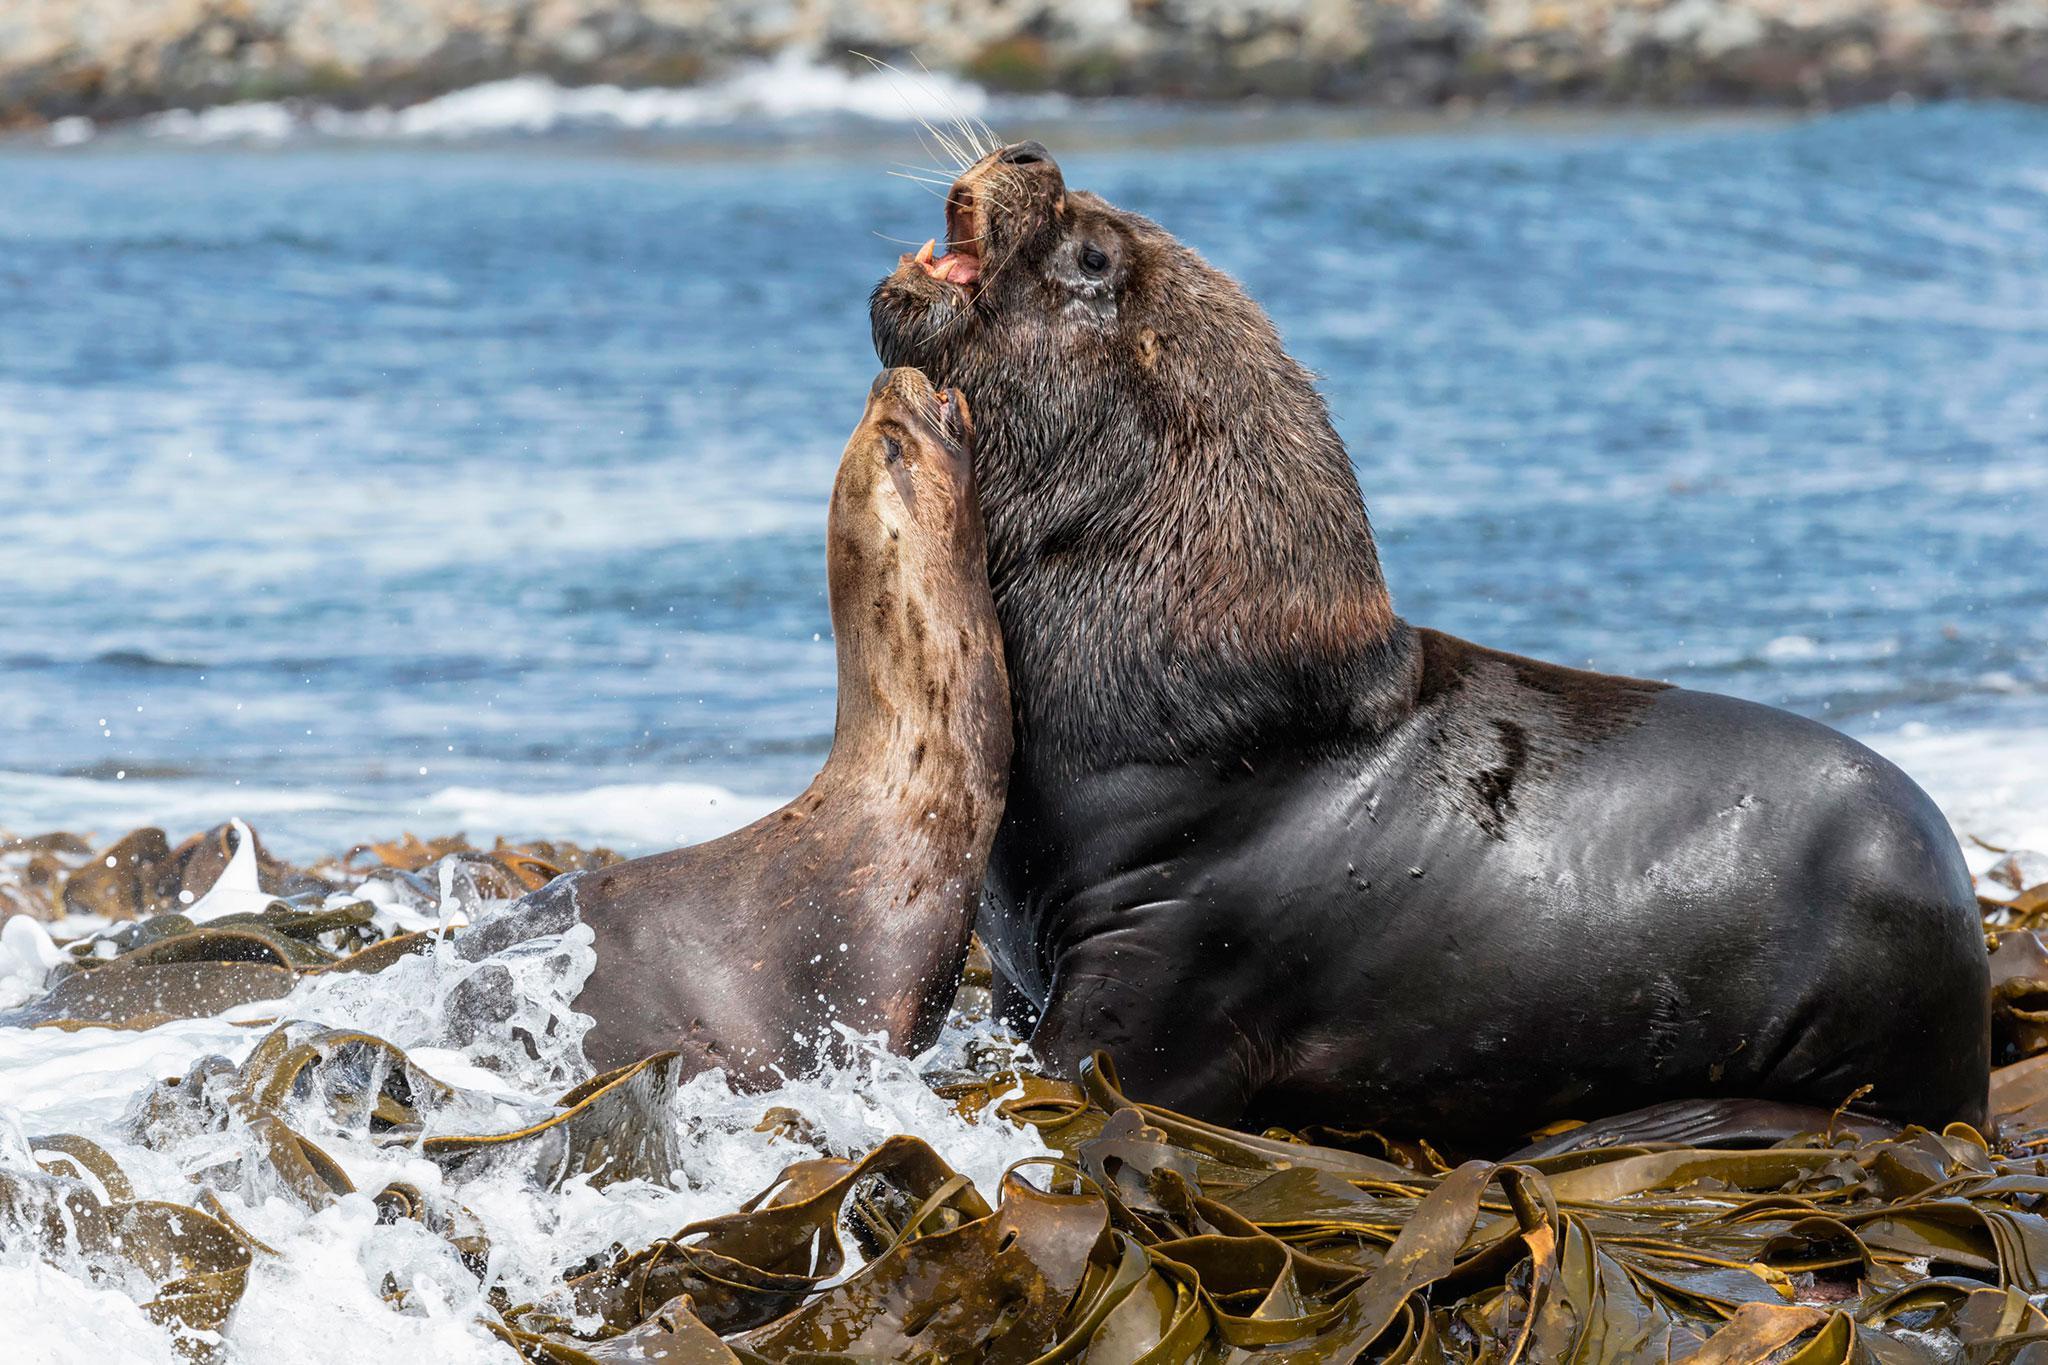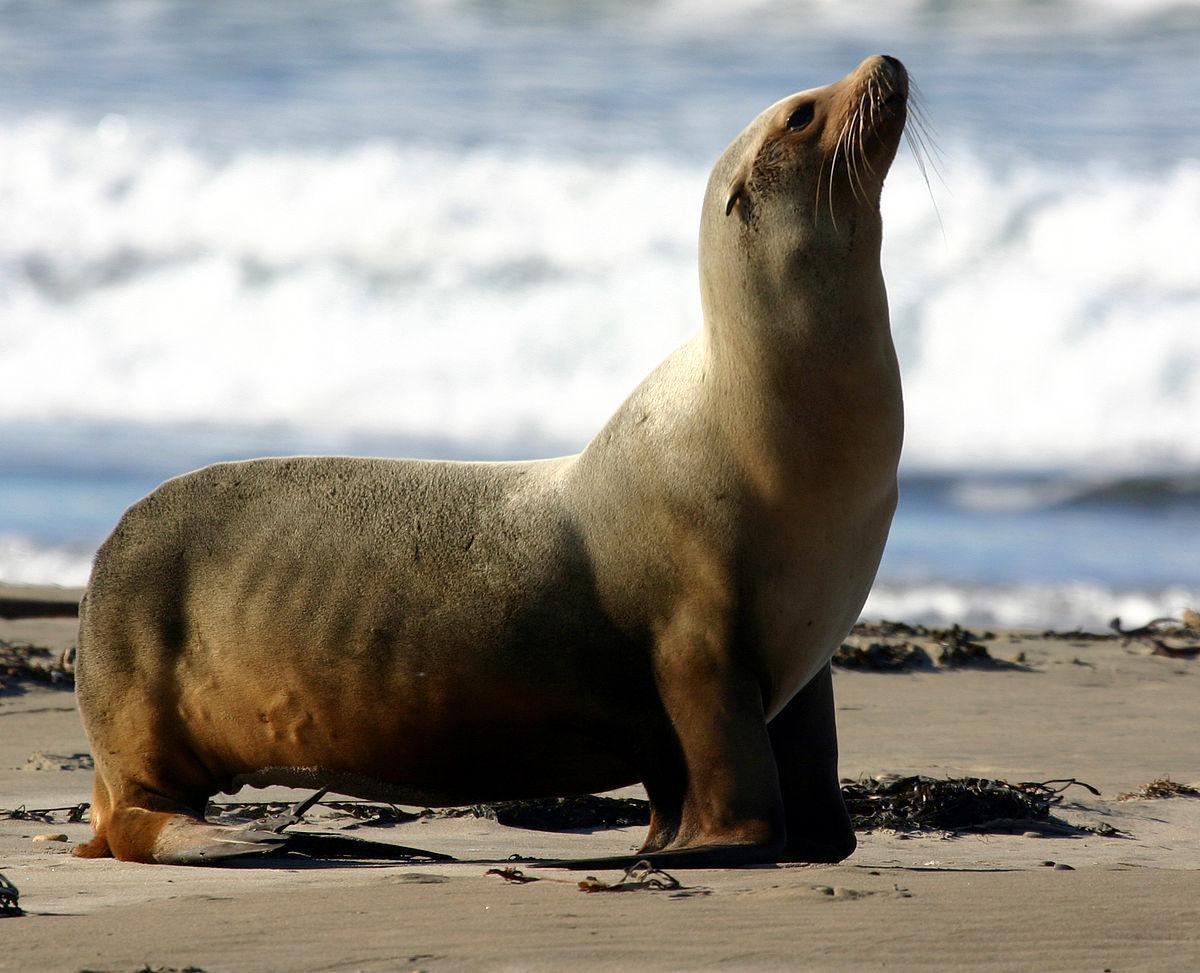The first image is the image on the left, the second image is the image on the right. Examine the images to the left and right. Is the description "Two seals appear to be communicating face to face." accurate? Answer yes or no. Yes. The first image is the image on the left, the second image is the image on the right. Analyze the images presented: Is the assertion "The right image shows just one young seal looking forward." valid? Answer yes or no. No. The first image is the image on the left, the second image is the image on the right. Given the left and right images, does the statement "The lefthand image contains two different-sized seals, both with their heads upright." hold true? Answer yes or no. Yes. 